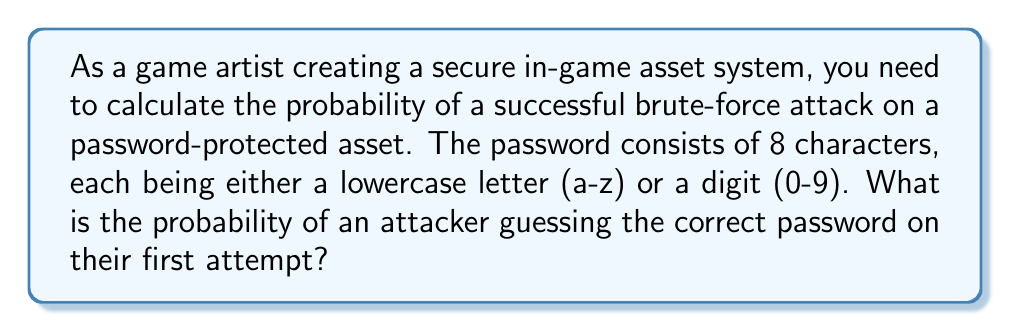Show me your answer to this math problem. To solve this problem, we need to follow these steps:

1. Calculate the total number of possible characters:
   - 26 lowercase letters (a-z)
   - 10 digits (0-9)
   Total: $26 + 10 = 36$ possible characters

2. Calculate the total number of possible passwords:
   - Each of the 8 characters can be any of the 36 possible characters
   - Total number of passwords: $36^8$

3. Calculate the probability of guessing the correct password:
   - The probability is 1 divided by the total number of possible passwords
   - Probability = $\frac{1}{36^8}$

4. Simplify the fraction:
   $$\frac{1}{36^8} = \frac{1}{2,821,109,907,456}$$

5. Convert to scientific notation:
   $$\frac{1}{2,821,109,907,456} \approx 3.544 \times 10^{-13}$$

Therefore, the probability of an attacker guessing the correct password on their first attempt is approximately $3.544 \times 10^{-13}$.
Answer: $3.544 \times 10^{-13}$ 